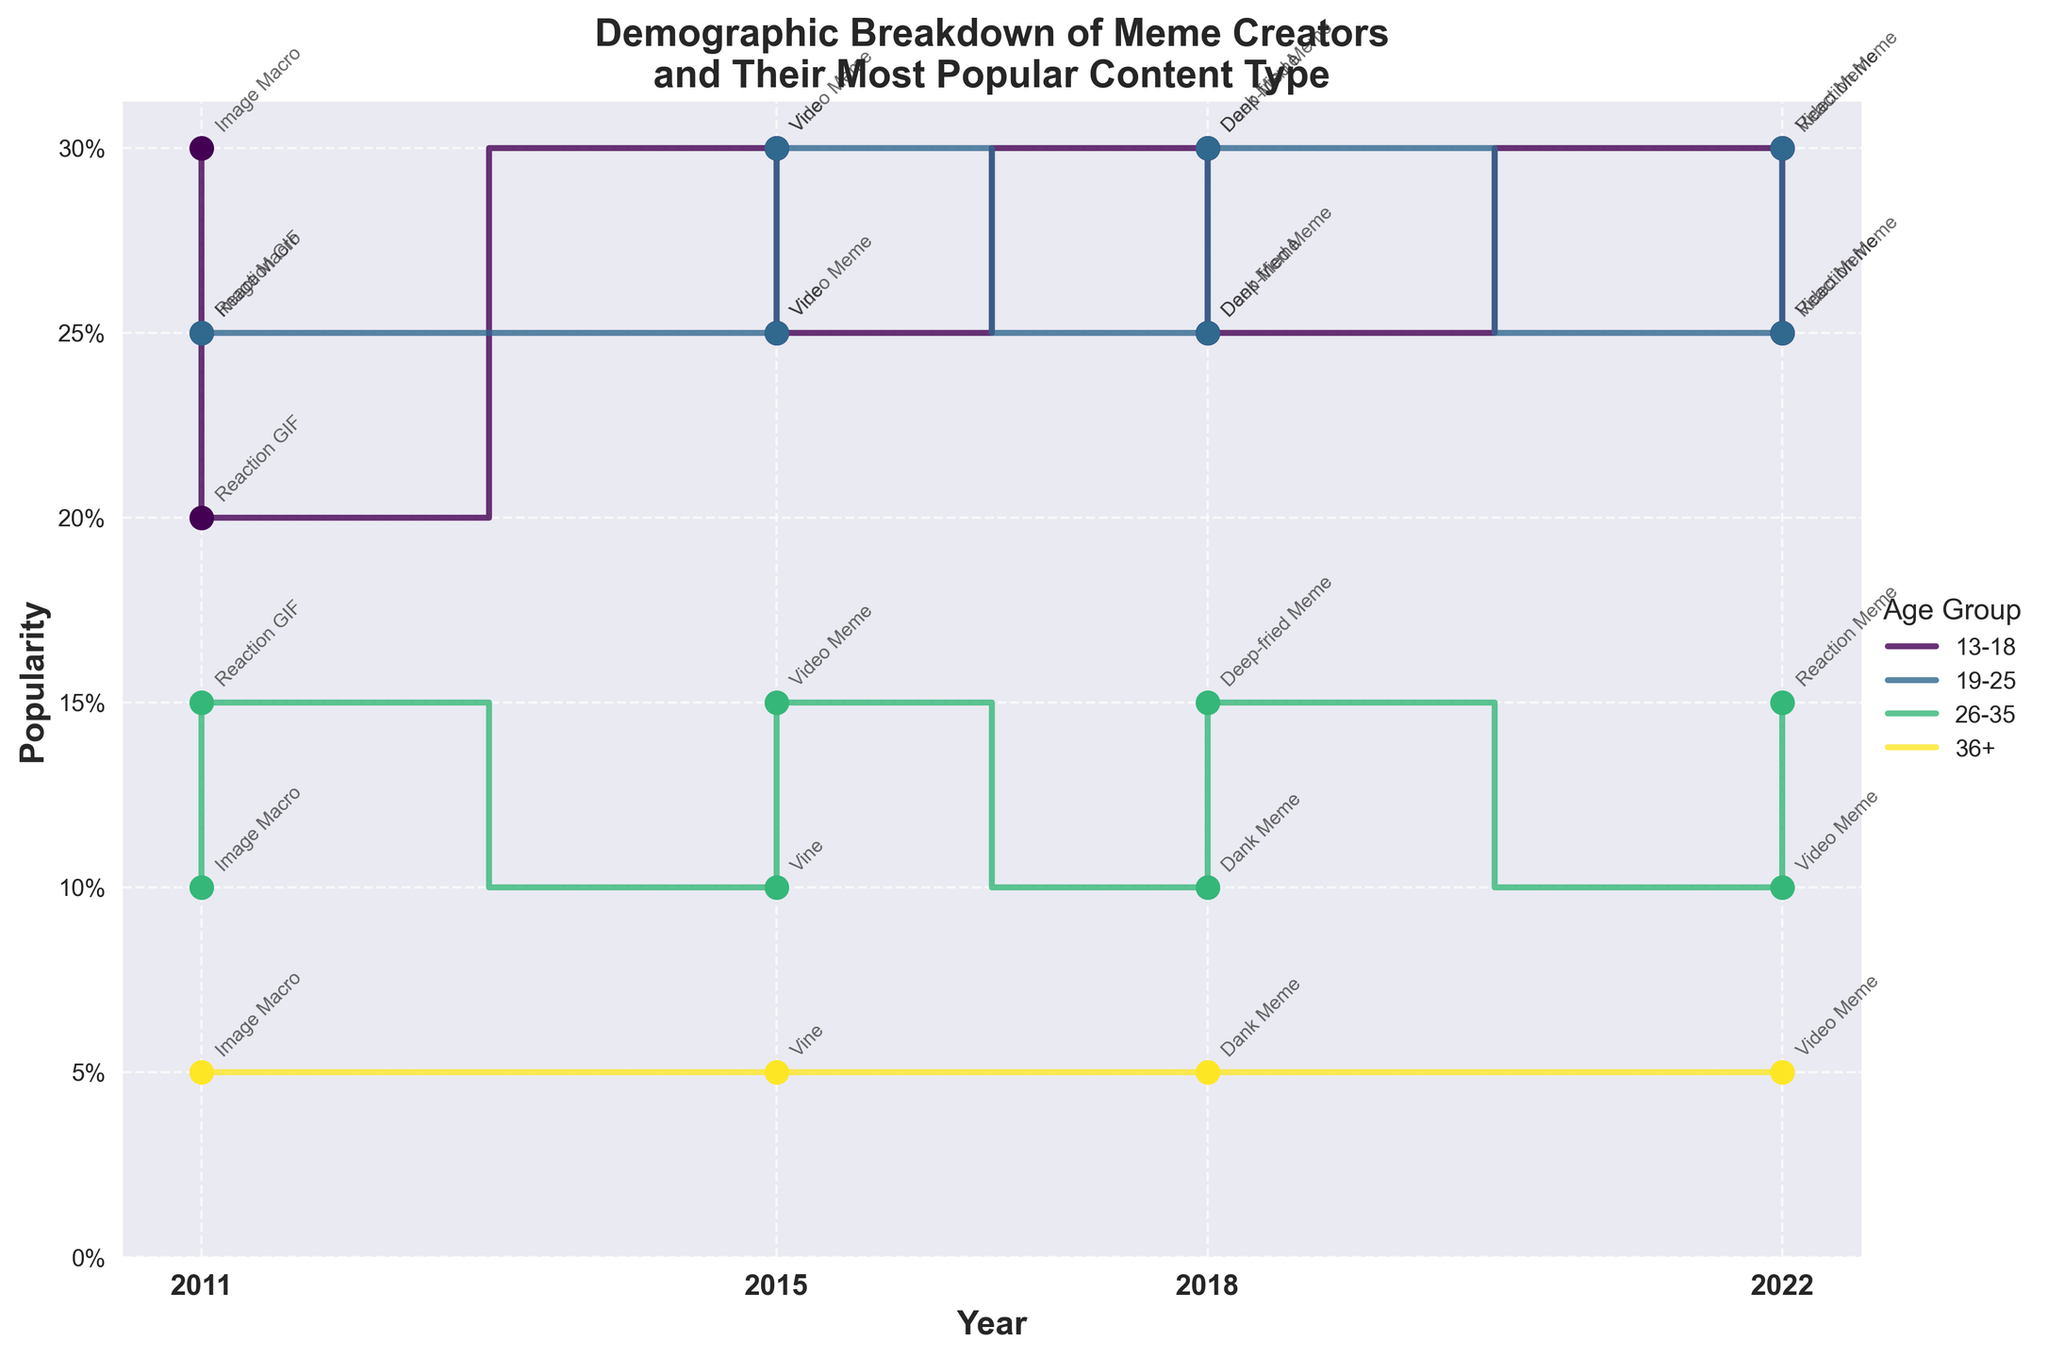What's the title of the figure? The title of a figure is generally found at the top. It summarizes the main content of the figure. Here, the title is clearly at the top of the image.
Answer: Demographic Breakdown of Meme Creators and Their Most Popular Content Type What is the x-axis representing? The x-axis typically shows the progression or categories being analyzed. In this figure, the x-axis is labeled "Year," and the tick marks indicate distinct years.
Answer: Year What age group had the highest popularity of meme creation in 2015? To determine this, look at the year 2015 on the x-axis and compare the popularity values for each age group. The age group with the highest value (the tallest step) is the most popular.
Answer: 13-18 Which age group consistently shows the lowest popularity across all years? This question requires observing the trend across all years for each age group. The age group with the smallest popularity values for every year is the answer. The lowest steps across all years belong to this age group.
Answer: 36+ How did the popularity of the '13-18' age group change from 2011 to 2022? First, locate the '13-18' age group data points for each year on the x-axis. Compare the popularity values from 2011 to 2022. Look for increases or decreases in the height of the steps.
Answer: Increased from 30% in 2011 to 30% in 2022 Which content type was popular among the '19-25' age group in 2018? Look at the '19-25' age group for the year 2018, and find the corresponding data point. The annotations next to the data points indicate the content type. For '19-25' in 2018, observe which content type is annotated.
Answer: Deep-fried Meme By how much did the popularity of video memes change for the '19-25' age group from 2015 to 2022? Identify the '19-25' age group's video meme popularity for both 2015 and 2022. Subtract the 2015 value from the 2022 value. For 2015 it's 30% with video memes and for 2022 it's 25%. Hence, a drop of 5% happened.
Answer: Decreased by 5% Which year had the most varied content types across different age groups? To answer this, look at the annotated content types for each year and count the number of distinct content types mentioned. The year with the highest count of unique content types is the answer.
Answer: 2018 Between 26-35 and 36+ age groups, which one showed an increase in the popularity of meme creation from 2011 to 2018? Compare the popularity values from 2011 to 2018 for both age groups. Determine which age group shows an increase in the height of the steps between these years. 26-35 increased from 10% to 10% & 36+ increased from 5% to 5%, both remained the same.
Answer: None 